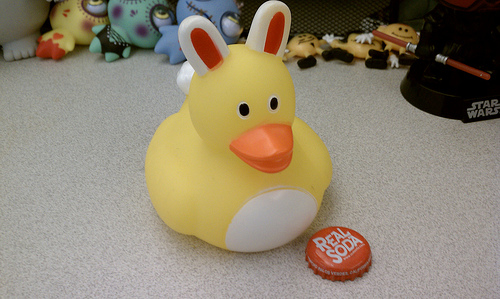<image>
Is the bunny ears on the rubber duck? Yes. Looking at the image, I can see the bunny ears is positioned on top of the rubber duck, with the rubber duck providing support. 